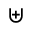Convert formula to latex. <formula><loc_0><loc_0><loc_500><loc_500>\uplus</formula> 